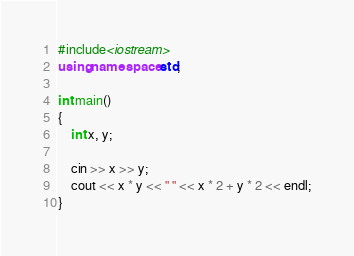Convert code to text. <code><loc_0><loc_0><loc_500><loc_500><_C++_>#include<iostream>
using namespace std;

int main()
{
	int x, y;

	cin >> x >> y;
	cout << x * y << " " << x * 2 + y * 2 << endl;
}</code> 